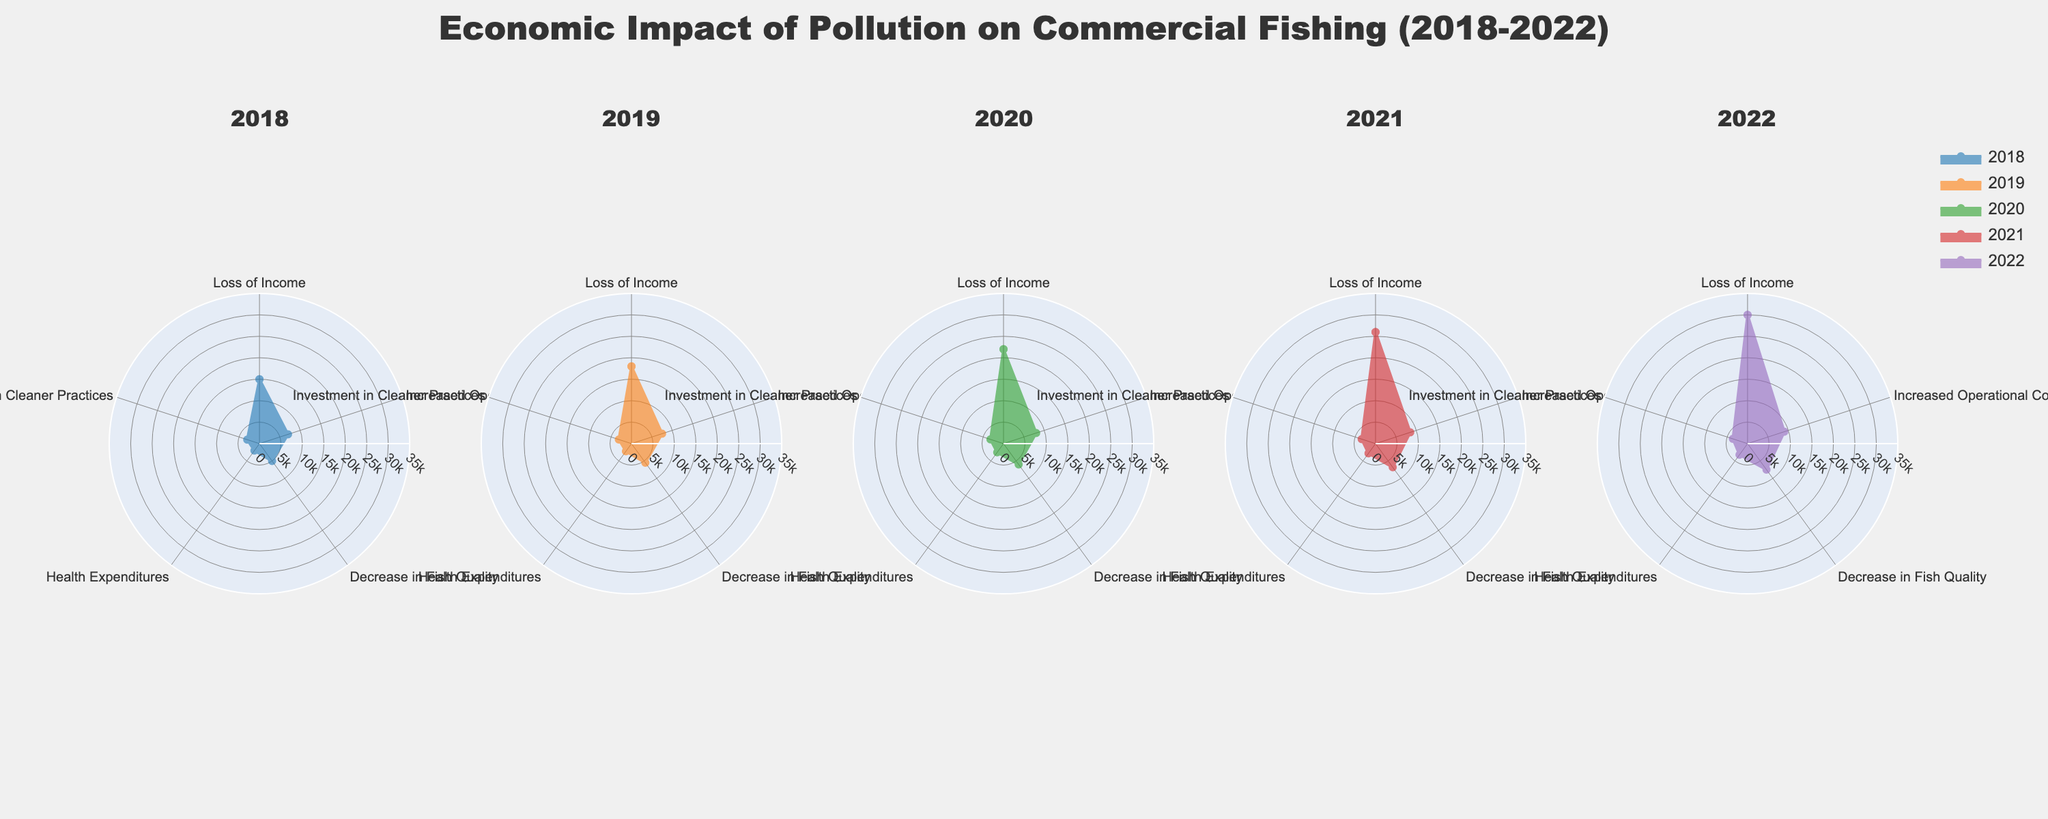What is the highest value in the subplot for 2022? Looking at the radar chart for 2022, the highest value is for "Loss of Income," reaching 30,000.
Answer: 30,000 How did the "Health Expenditures" change from 2018 to 2022? In 2018, the value for "Health Expenditures" is 2,000, and by 2022, it increases to 3,200. Therefore, the change is 3,200 - 2,000 = 1,200.
Answer: 1,200 Which category consistently shows an increase across all years? By examining the values across all years, "Loss of Income" shows a steady increase from 15,000 in 2018 to 30,000 in 2022.
Answer: Loss of Income What is the average value for "Increased Operational Costs" over the 5 years? The values for "Increased Operational Costs" are 7,000, 7,500, 8,000, 8,500, and 9,000. Summing them gives 40,000, and dividing by 5 gives the average 40,000/5 = 8,000.
Answer: 8,000 Which year had the highest total economic impact across all categories? Summing all categories for each year: 
2018: 15000+7000+5000+2000+3000 = 32000 
2019: 18000+7500+5500+2200+3100 = 36300 
2020: 22000+8000+6000+2500+3200 = 41700 
2021: 26000+8500+6800+2800+3400 = 47500 
2022: 30000+9000+7500+3200+3600 = 53300 
2022 has the highest total.
Answer: 2022 Compared to 2020, how much did "Decrease in Fish Quality" increase by 2022? In 2020, "Decrease in Fish Quality" is 6,000 and in 2022 it's 7,500. The increase is 7,500 - 6,000 = 1,500.
Answer: 1,500 What is the overall trend for "Investment in Cleaner Practices" from 2018 to 2022? Observing "Investment in Cleaner Practices" over the years shows a steady increase from 3,000 in 2018 to 3,600 in 2022.
Answer: Increasing During which year was "Increase in Operational Costs" the lowest, and what was the value? The lowest "Increase in Operational Costs" is in 2018 at 7,000.
Answer: 2018, 7,000 How does the "Loss of Income" in 2019 compare to 2021? The "Loss of Income" in 2019 is 18,000 compared to 26,000 in 2021. The difference is 26,000 - 18,000 = 8,000.
Answer: 8,000 higher 